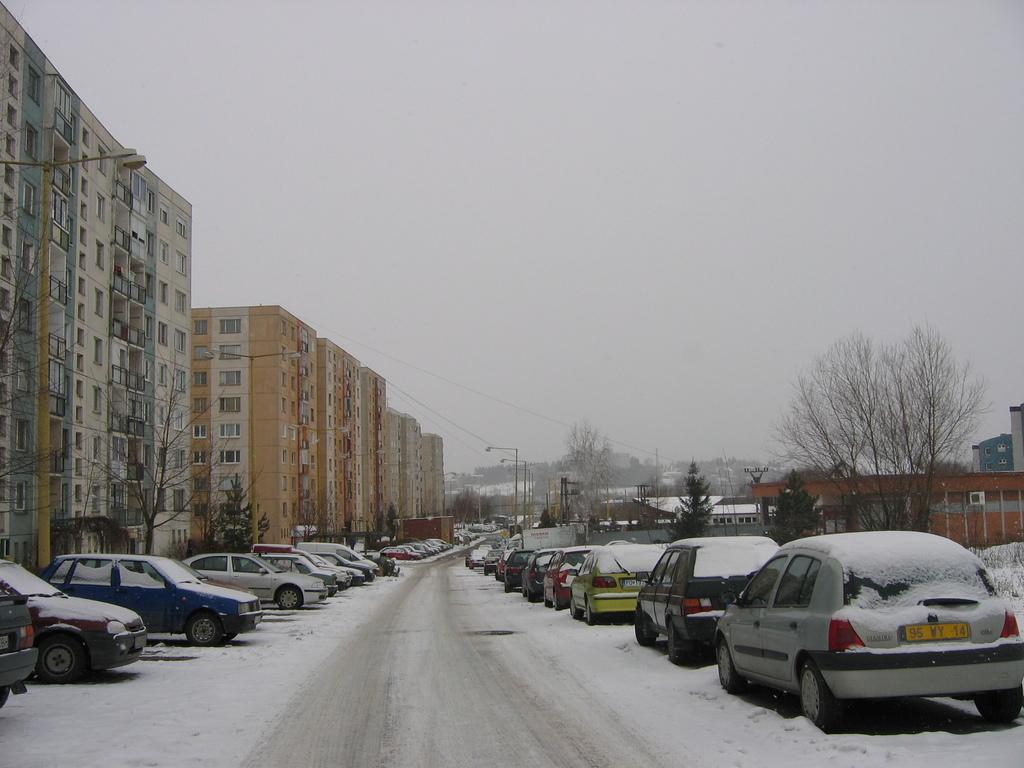What type of structures can be seen in the image? There are houses in the image. What other natural elements are present in the image? There are trees in the image. Are there any vehicles visible in the image? Yes, there are cars in the image. What else can be seen in the image that might be related to infrastructure? There are poles in the image. What might be the weather condition based on the image? The image appears to have snow. Can you see any bats hanging from the trees in the image? There are no bats visible in the image; only houses, trees, cars, poles, and snow are present. What type of shoes can be seen on the people in the image? There are no people visible in the image, so it is not possible to determine what type of shoes they might be wearing. 